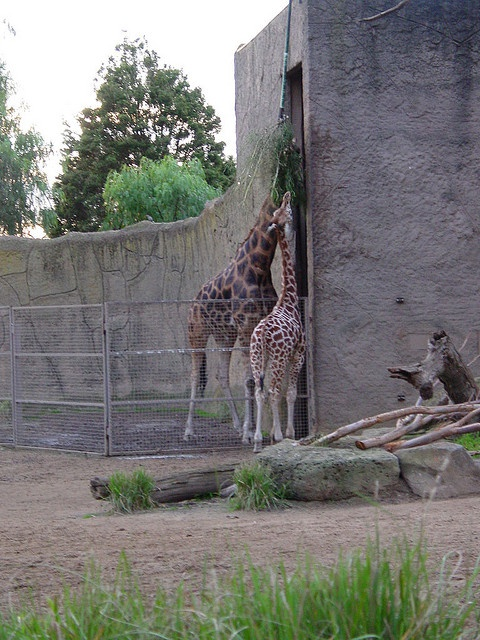Describe the objects in this image and their specific colors. I can see giraffe in white, gray, and black tones, giraffe in white, gray, black, and maroon tones, and giraffe in white, gray, darkgray, and black tones in this image. 